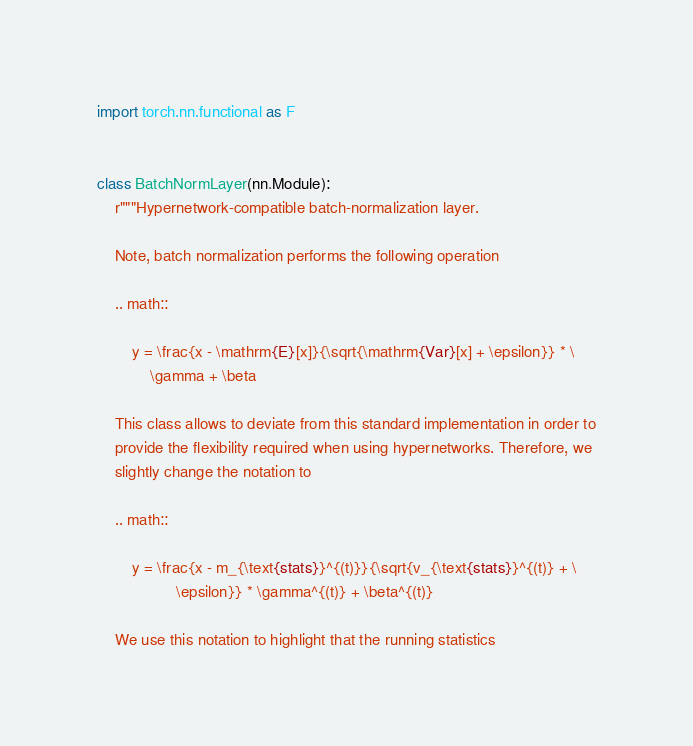Convert code to text. <code><loc_0><loc_0><loc_500><loc_500><_Python_>import torch.nn.functional as F


class BatchNormLayer(nn.Module):
    r"""Hypernetwork-compatible batch-normalization layer.

    Note, batch normalization performs the following operation

    .. math::

        y = \frac{x - \mathrm{E}[x]}{\sqrt{\mathrm{Var}[x] + \epsilon}} * \
            \gamma + \beta

    This class allows to deviate from this standard implementation in order to
    provide the flexibility required when using hypernetworks. Therefore, we
    slightly change the notation to

    .. math::

        y = \frac{x - m_{\text{stats}}^{(t)}}{\sqrt{v_{\text{stats}}^{(t)} + \
                  \epsilon}} * \gamma^{(t)} + \beta^{(t)}

    We use this notation to highlight that the running statistics</code> 